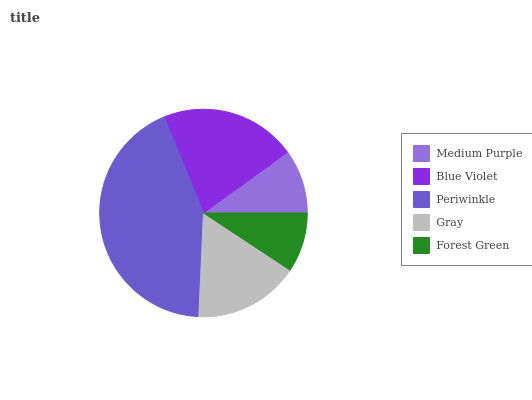Is Forest Green the minimum?
Answer yes or no. Yes. Is Periwinkle the maximum?
Answer yes or no. Yes. Is Blue Violet the minimum?
Answer yes or no. No. Is Blue Violet the maximum?
Answer yes or no. No. Is Blue Violet greater than Medium Purple?
Answer yes or no. Yes. Is Medium Purple less than Blue Violet?
Answer yes or no. Yes. Is Medium Purple greater than Blue Violet?
Answer yes or no. No. Is Blue Violet less than Medium Purple?
Answer yes or no. No. Is Gray the high median?
Answer yes or no. Yes. Is Gray the low median?
Answer yes or no. Yes. Is Medium Purple the high median?
Answer yes or no. No. Is Periwinkle the low median?
Answer yes or no. No. 